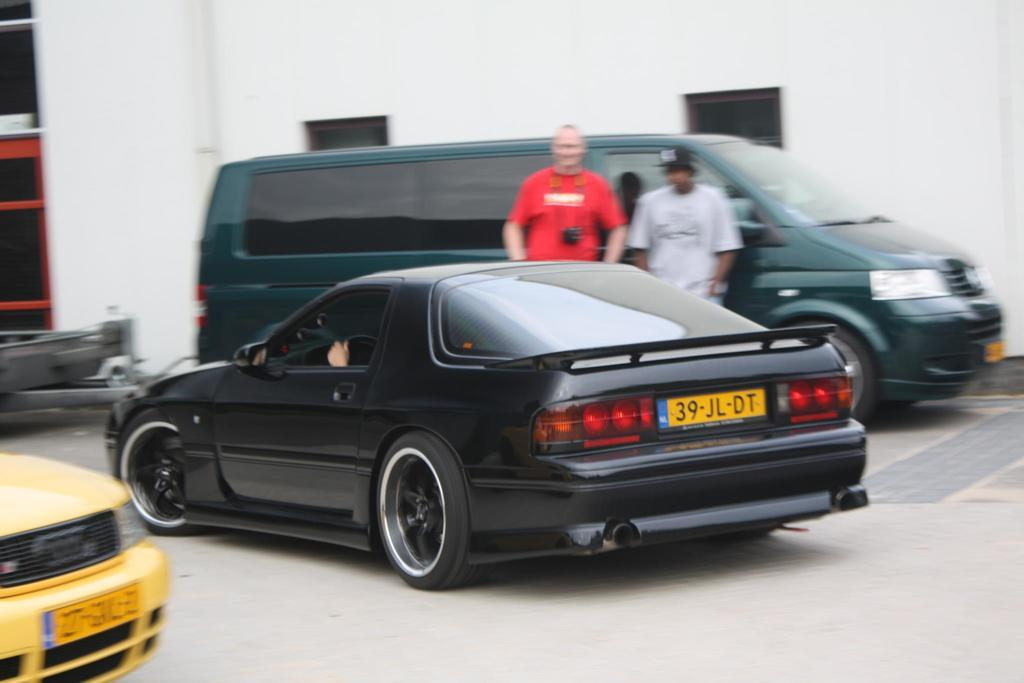What is located in the center of the image? There are vehicles and people in the center of the image. What can be seen in the background of the image? There are buildings in the background of the image. What is at the bottom of the image? There is a road at the bottom of the image. What type of answer can be seen in the image? There is no answer present in the image; it features vehicles, people, buildings, and a road. 